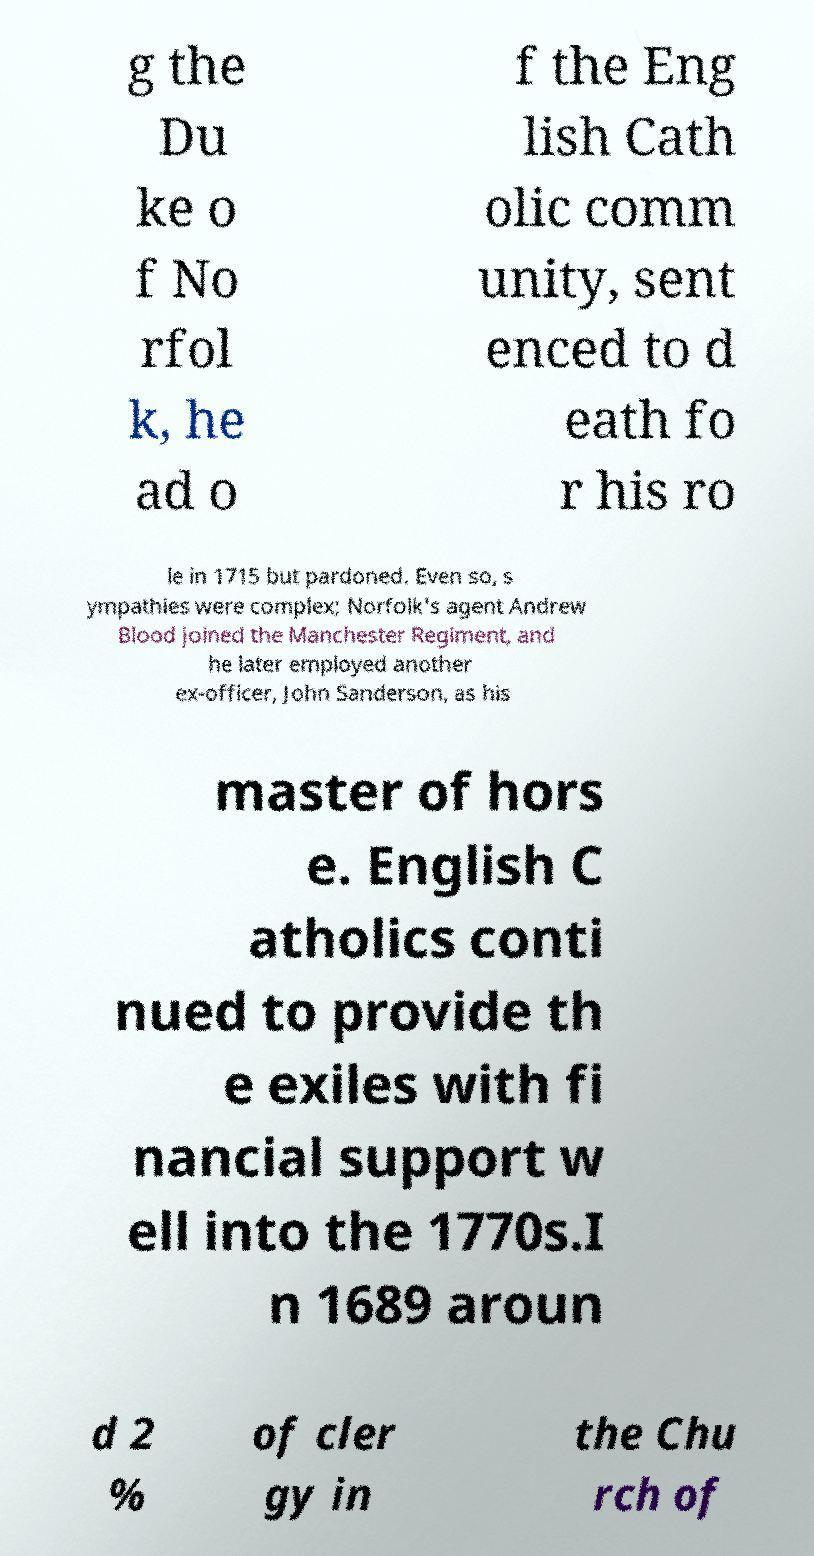Please read and relay the text visible in this image. What does it say? g the Du ke o f No rfol k, he ad o f the Eng lish Cath olic comm unity, sent enced to d eath fo r his ro le in 1715 but pardoned. Even so, s ympathies were complex; Norfolk's agent Andrew Blood joined the Manchester Regiment, and he later employed another ex-officer, John Sanderson, as his master of hors e. English C atholics conti nued to provide th e exiles with fi nancial support w ell into the 1770s.I n 1689 aroun d 2 % of cler gy in the Chu rch of 